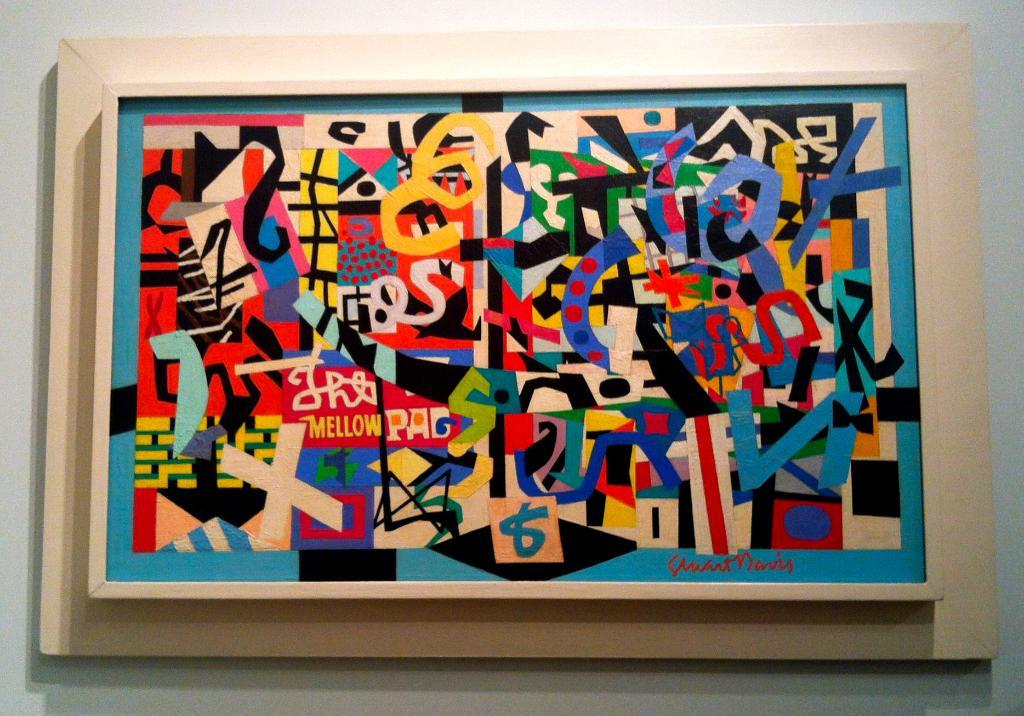Provide a one-sentence caption for the provided image. The lower left quadrant has a yellow word of mellow. 